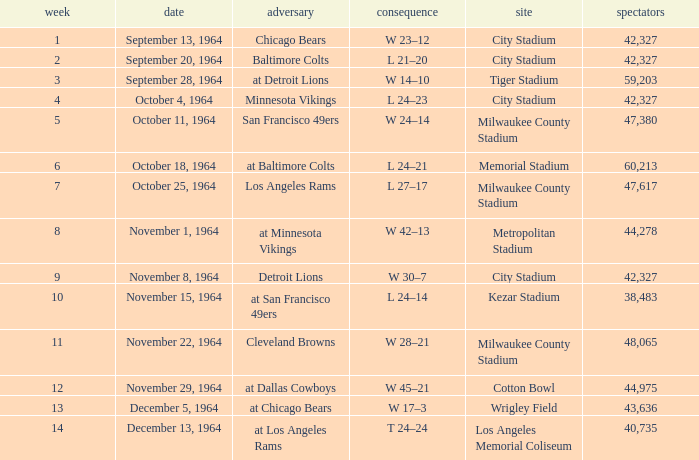What is the average week of the game on November 22, 1964 attended by 48,065? None. 